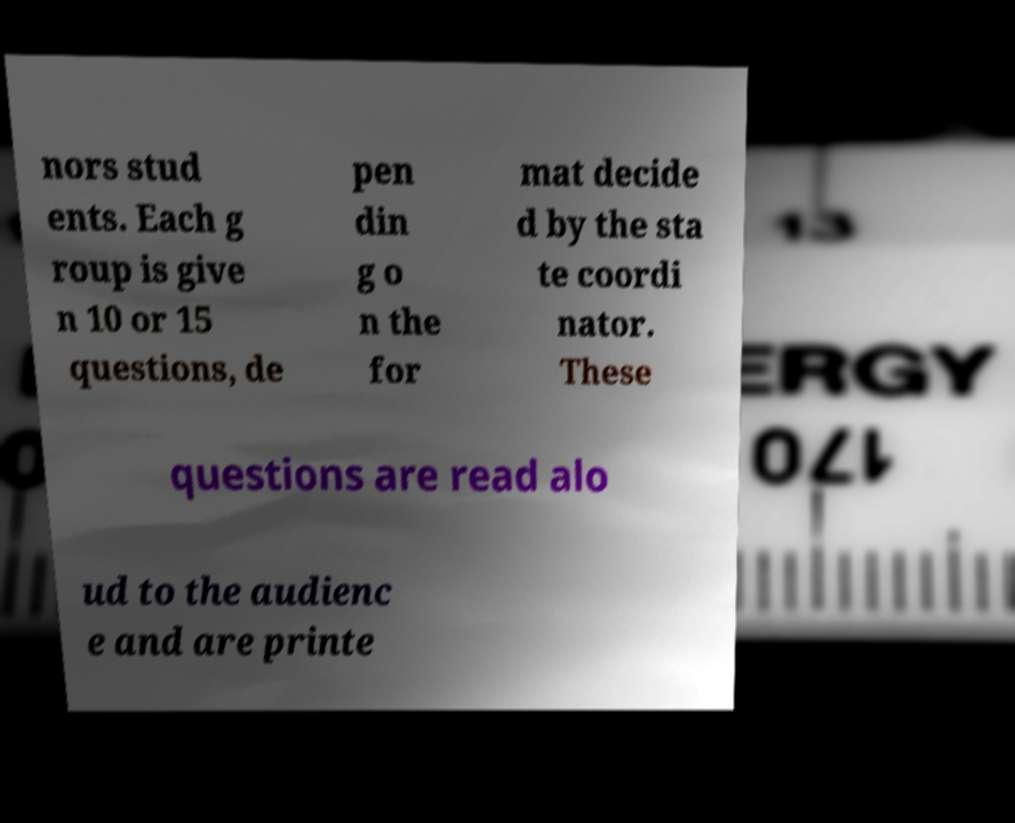Please identify and transcribe the text found in this image. nors stud ents. Each g roup is give n 10 or 15 questions, de pen din g o n the for mat decide d by the sta te coordi nator. These questions are read alo ud to the audienc e and are printe 